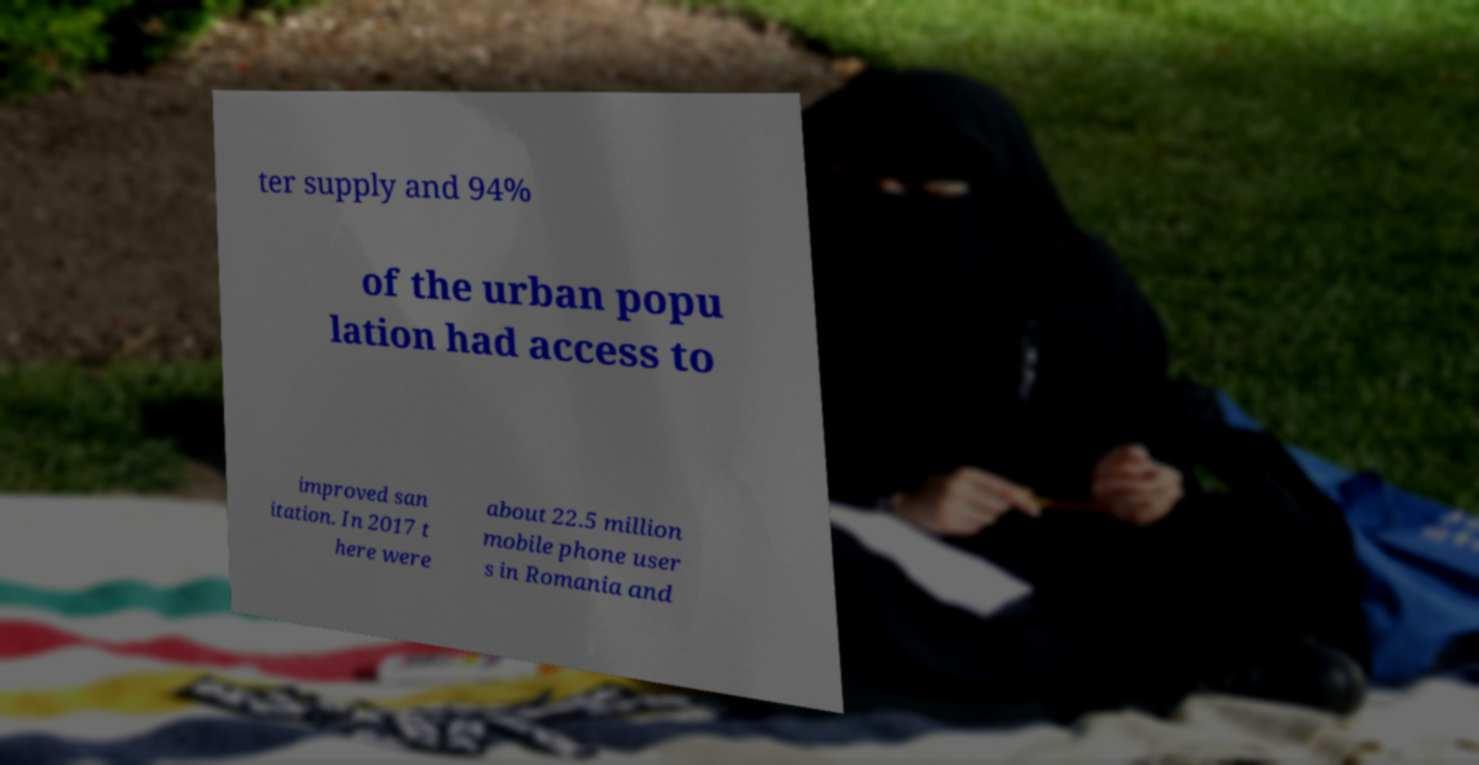Please read and relay the text visible in this image. What does it say? ter supply and 94% of the urban popu lation had access to improved san itation. In 2017 t here were about 22.5 million mobile phone user s in Romania and 